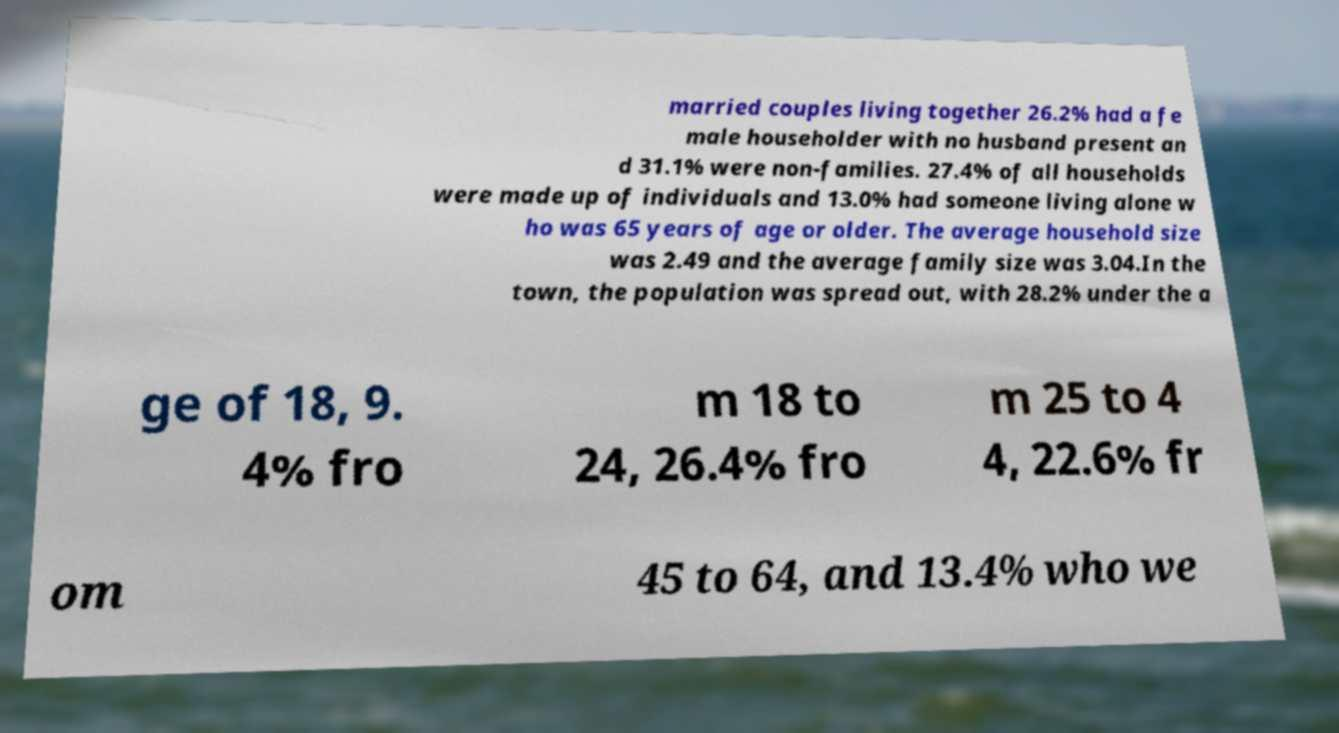There's text embedded in this image that I need extracted. Can you transcribe it verbatim? married couples living together 26.2% had a fe male householder with no husband present an d 31.1% were non-families. 27.4% of all households were made up of individuals and 13.0% had someone living alone w ho was 65 years of age or older. The average household size was 2.49 and the average family size was 3.04.In the town, the population was spread out, with 28.2% under the a ge of 18, 9. 4% fro m 18 to 24, 26.4% fro m 25 to 4 4, 22.6% fr om 45 to 64, and 13.4% who we 